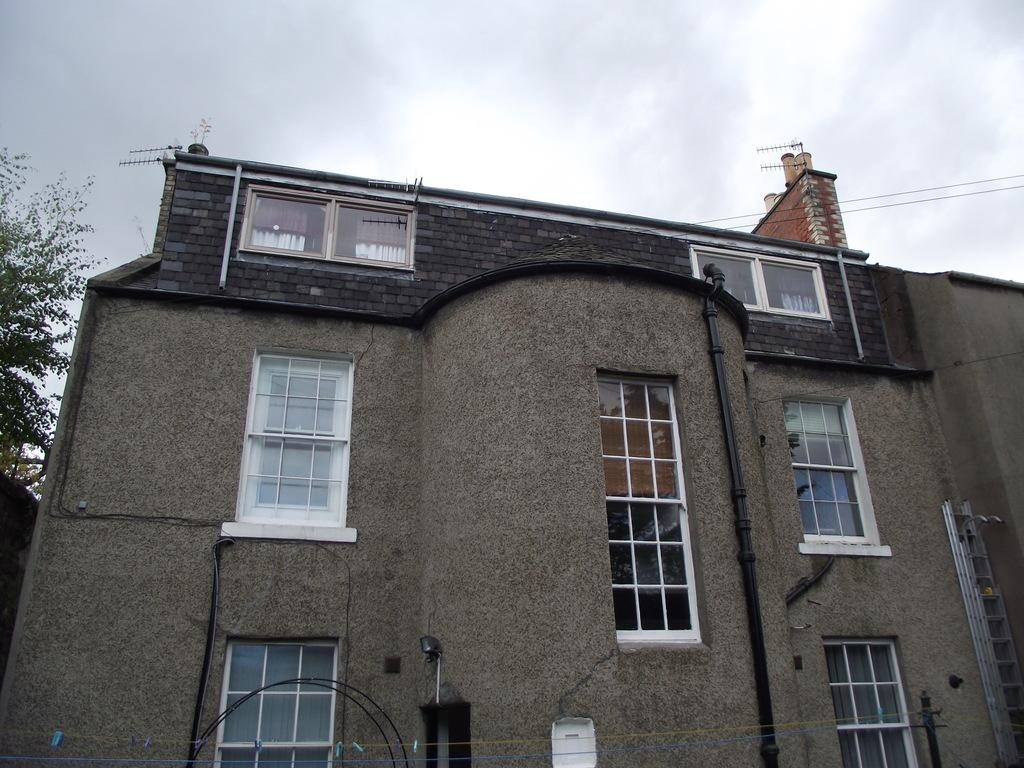What type of structure is present in the image? There is a building in the image. Where is the tree located in the image? The tree is on the left side of the image. What is at the bottom of the image? There is a pole at the bottom of the image. What else can be seen in the image besides the building and tree? Wires are visible in the image. What is visible in the background of the image? The sky is visible in the background of the image. How many eggs are being carried by the yak in the image? There is no yak or eggs present in the image. What color is the balloon tied to the tree in the image? There is no balloon present in the image. 